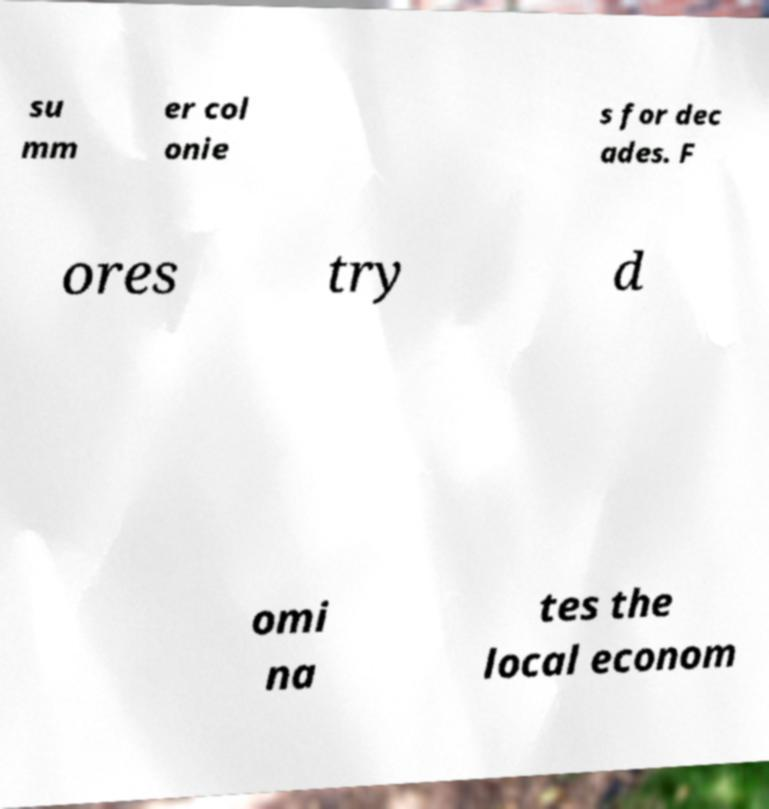For documentation purposes, I need the text within this image transcribed. Could you provide that? su mm er col onie s for dec ades. F ores try d omi na tes the local econom 